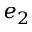Convert formula to latex. <formula><loc_0><loc_0><loc_500><loc_500>e _ { 2 }</formula> 